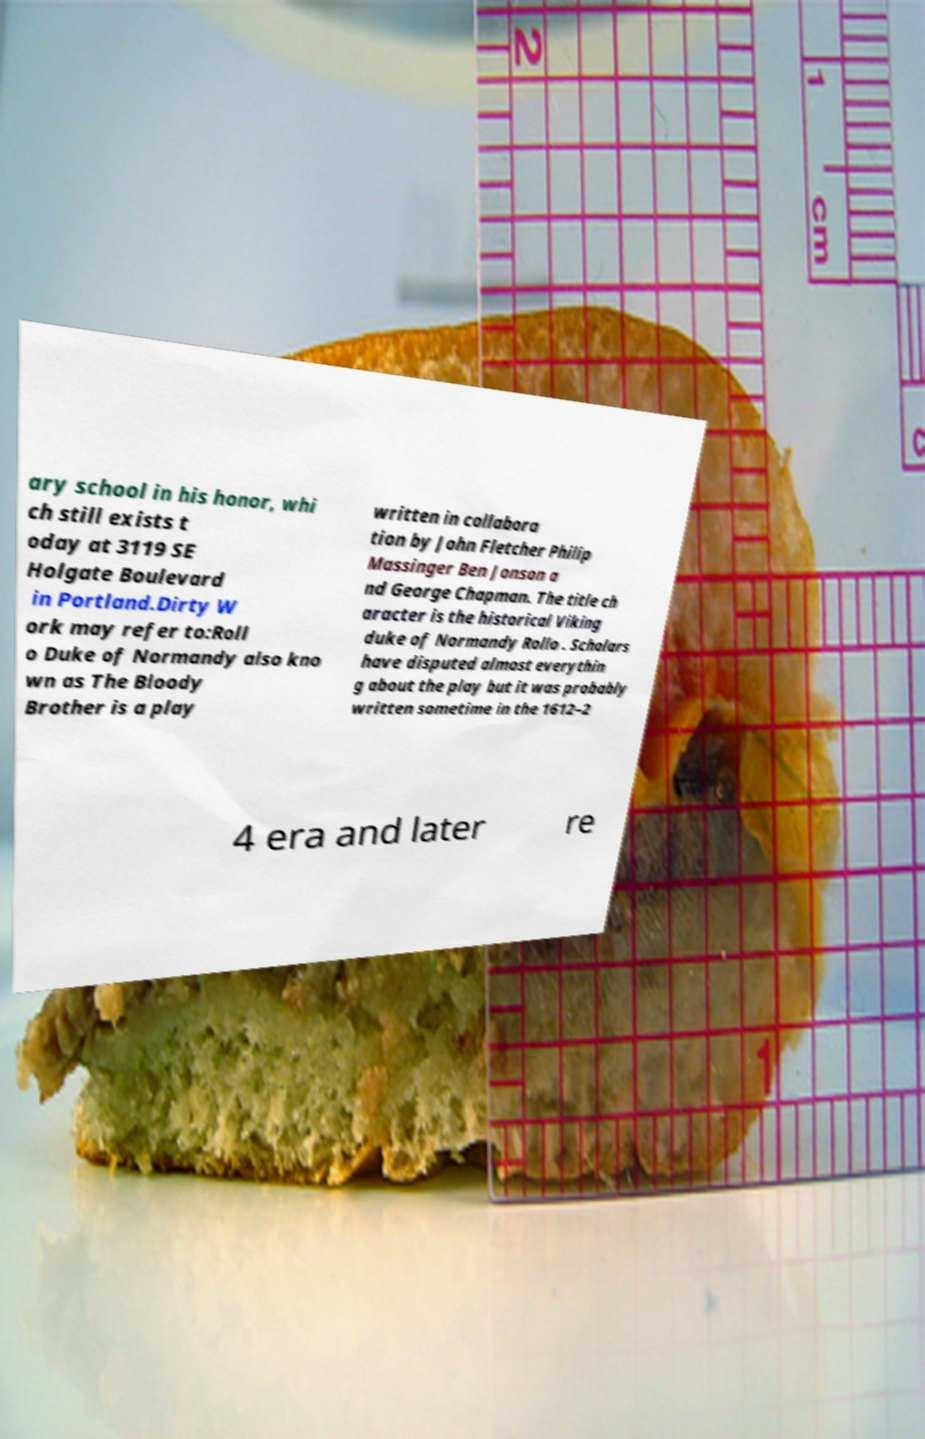Can you read and provide the text displayed in the image?This photo seems to have some interesting text. Can you extract and type it out for me? ary school in his honor, whi ch still exists t oday at 3119 SE Holgate Boulevard in Portland.Dirty W ork may refer to:Roll o Duke of Normandy also kno wn as The Bloody Brother is a play written in collabora tion by John Fletcher Philip Massinger Ben Jonson a nd George Chapman. The title ch aracter is the historical Viking duke of Normandy Rollo . Scholars have disputed almost everythin g about the play but it was probably written sometime in the 1612–2 4 era and later re 